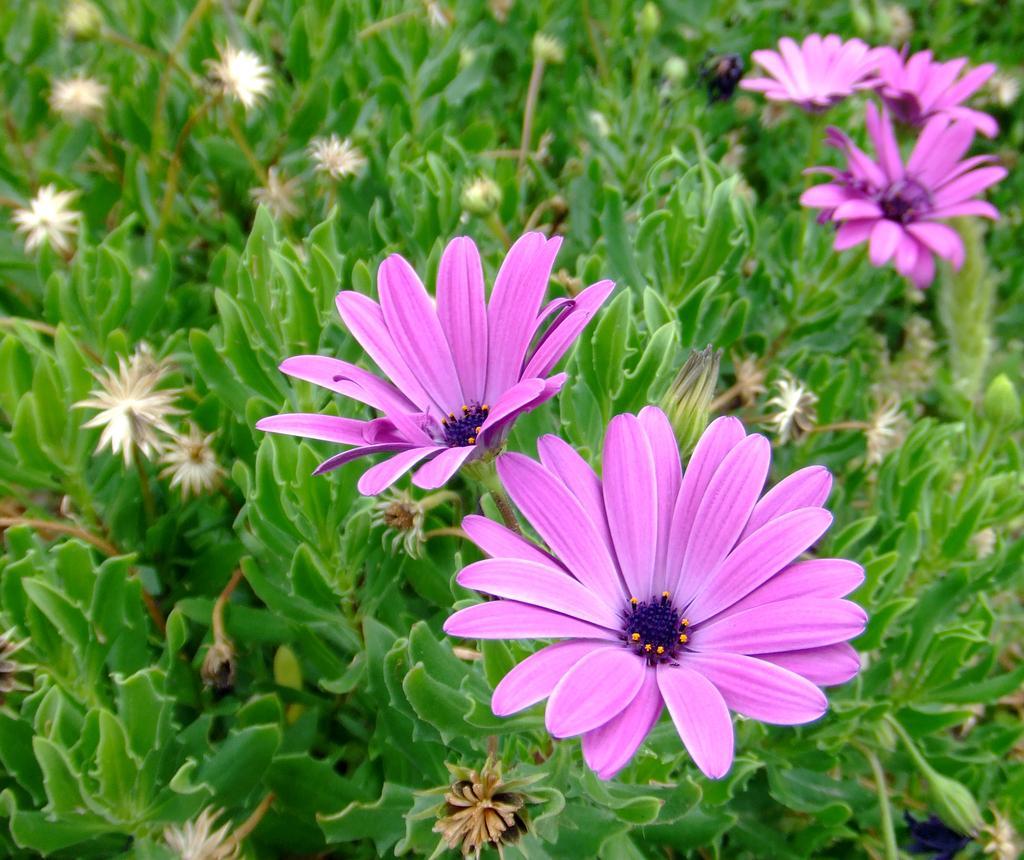In one or two sentences, can you explain what this image depicts? In this image we can see flowers and green leaves. 